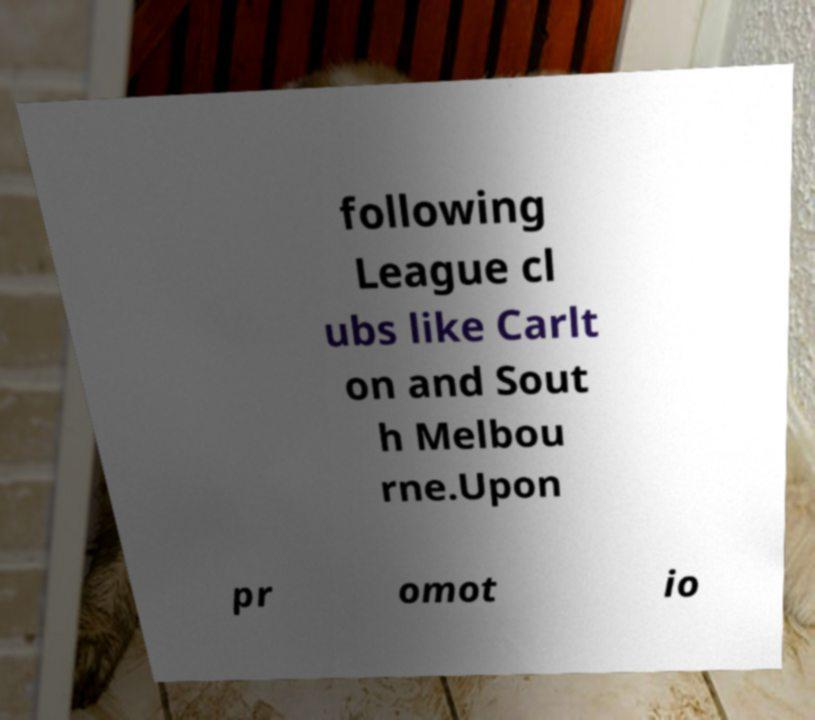Please identify and transcribe the text found in this image. following League cl ubs like Carlt on and Sout h Melbou rne.Upon pr omot io 